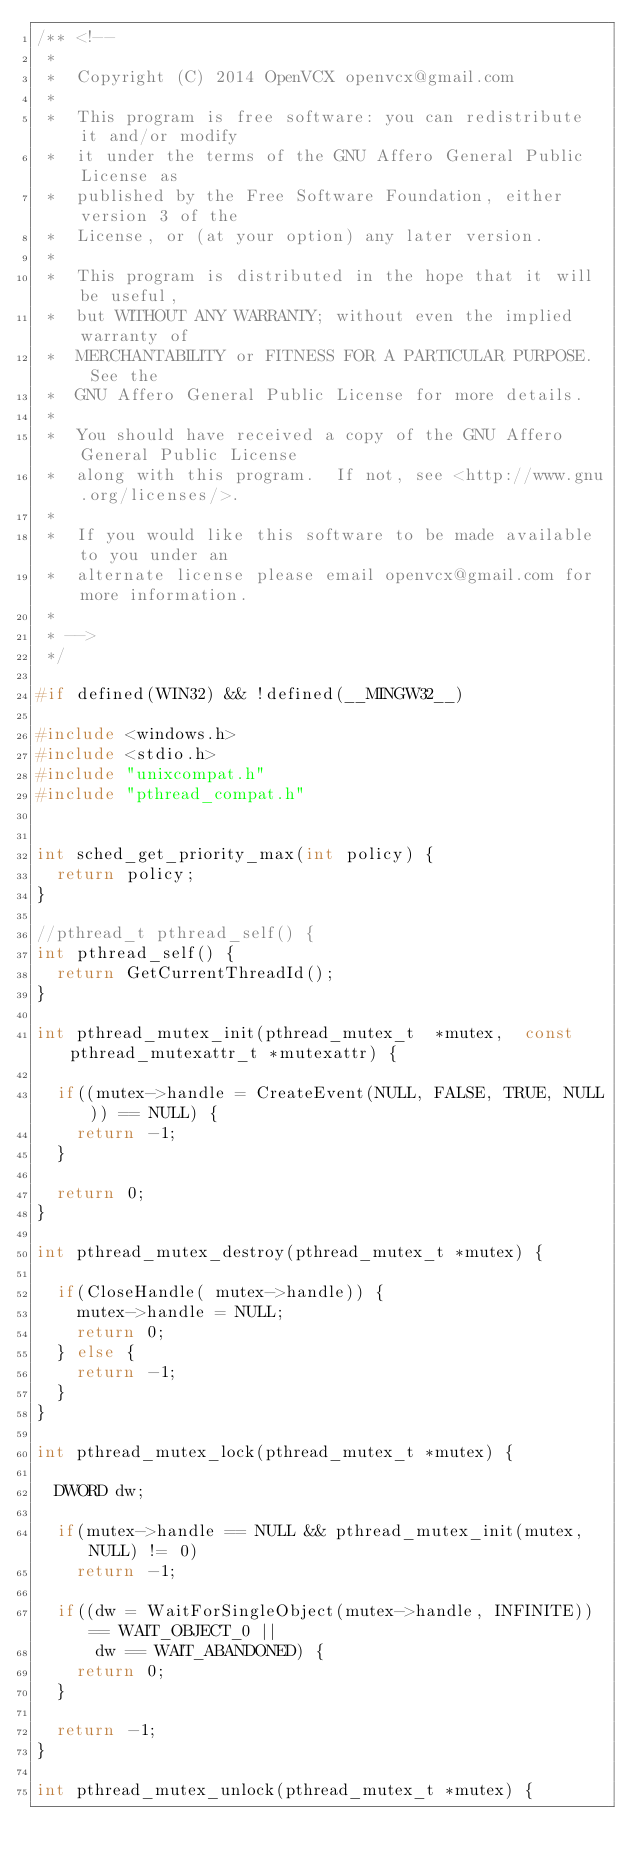Convert code to text. <code><loc_0><loc_0><loc_500><loc_500><_C_>/** <!--
 *
 *  Copyright (C) 2014 OpenVCX openvcx@gmail.com
 *
 *  This program is free software: you can redistribute it and/or modify
 *  it under the terms of the GNU Affero General Public License as
 *  published by the Free Software Foundation, either version 3 of the
 *  License, or (at your option) any later version.
 *
 *  This program is distributed in the hope that it will be useful,
 *  but WITHOUT ANY WARRANTY; without even the implied warranty of
 *  MERCHANTABILITY or FITNESS FOR A PARTICULAR PURPOSE.  See the
 *  GNU Affero General Public License for more details.
 *
 *  You should have received a copy of the GNU Affero General Public License
 *  along with this program.  If not, see <http://www.gnu.org/licenses/>.
 *
 *  If you would like this software to be made available to you under an 
 *  alternate license please email openvcx@gmail.com for more information.
 *
 * -->
 */

#if defined(WIN32) && !defined(__MINGW32__)

#include <windows.h>
#include <stdio.h>
#include "unixcompat.h"
#include "pthread_compat.h"


int sched_get_priority_max(int policy) {
  return policy;
}

//pthread_t pthread_self() {
int pthread_self() {
  return GetCurrentThreadId();
}

int pthread_mutex_init(pthread_mutex_t  *mutex,  const pthread_mutexattr_t *mutexattr) {

  if((mutex->handle = CreateEvent(NULL, FALSE, TRUE, NULL)) == NULL) {
    return -1;
  }

  return 0;
}

int pthread_mutex_destroy(pthread_mutex_t *mutex) {

  if(CloseHandle( mutex->handle)) {
    mutex->handle = NULL;
    return 0;
  } else {
    return -1;
  }
}

int pthread_mutex_lock(pthread_mutex_t *mutex) {

  DWORD dw;

  if(mutex->handle == NULL && pthread_mutex_init(mutex, NULL) != 0)
    return -1;
  
  if((dw = WaitForSingleObject(mutex->handle, INFINITE)) == WAIT_OBJECT_0 ||
      dw == WAIT_ABANDONED) {
    return 0;
  }

  return -1;
}

int pthread_mutex_unlock(pthread_mutex_t *mutex) {
</code> 